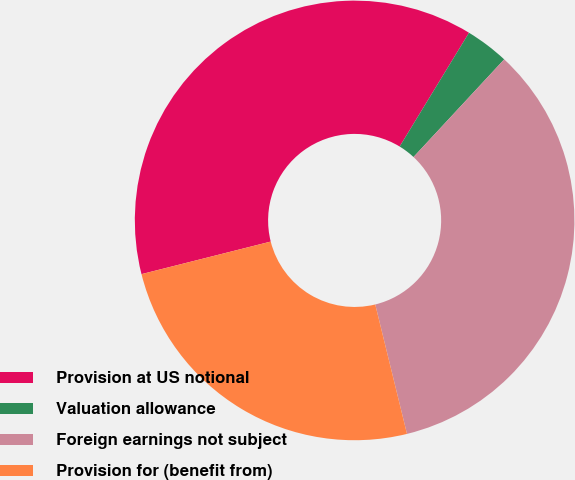<chart> <loc_0><loc_0><loc_500><loc_500><pie_chart><fcel>Provision at US notional<fcel>Valuation allowance<fcel>Foreign earnings not subject<fcel>Provision for (benefit from)<nl><fcel>37.64%<fcel>3.2%<fcel>34.26%<fcel>24.9%<nl></chart> 